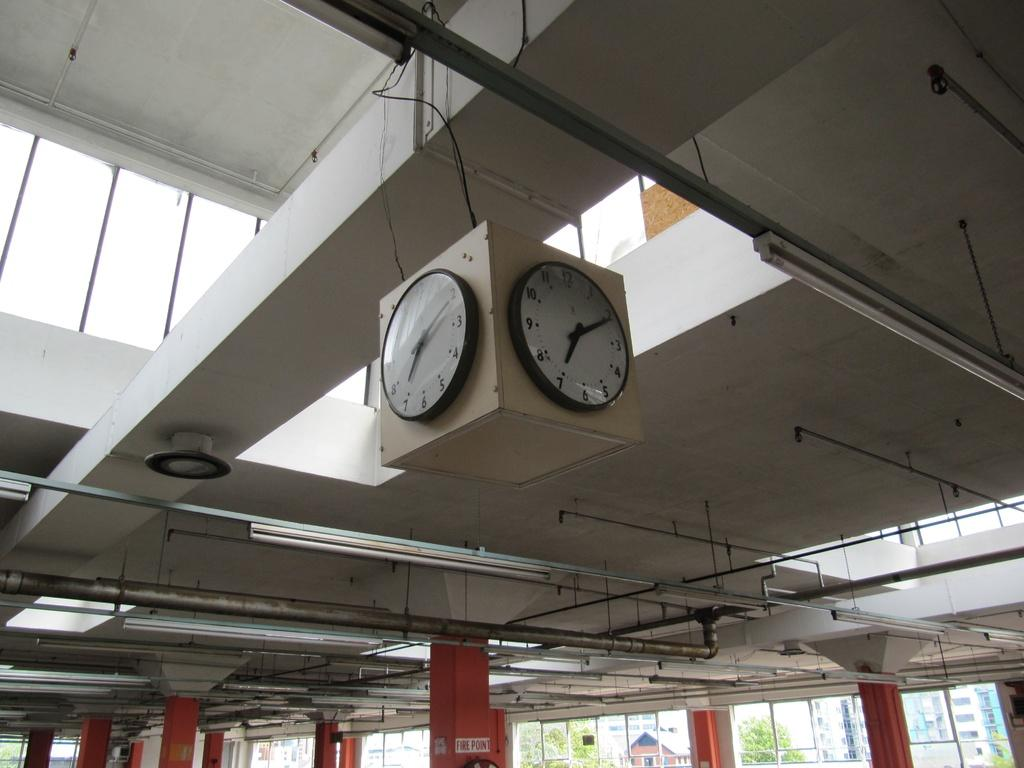<image>
Relay a brief, clear account of the picture shown. The inside of a building and two clocks near the ceiling both of which have the number 7 on them. 